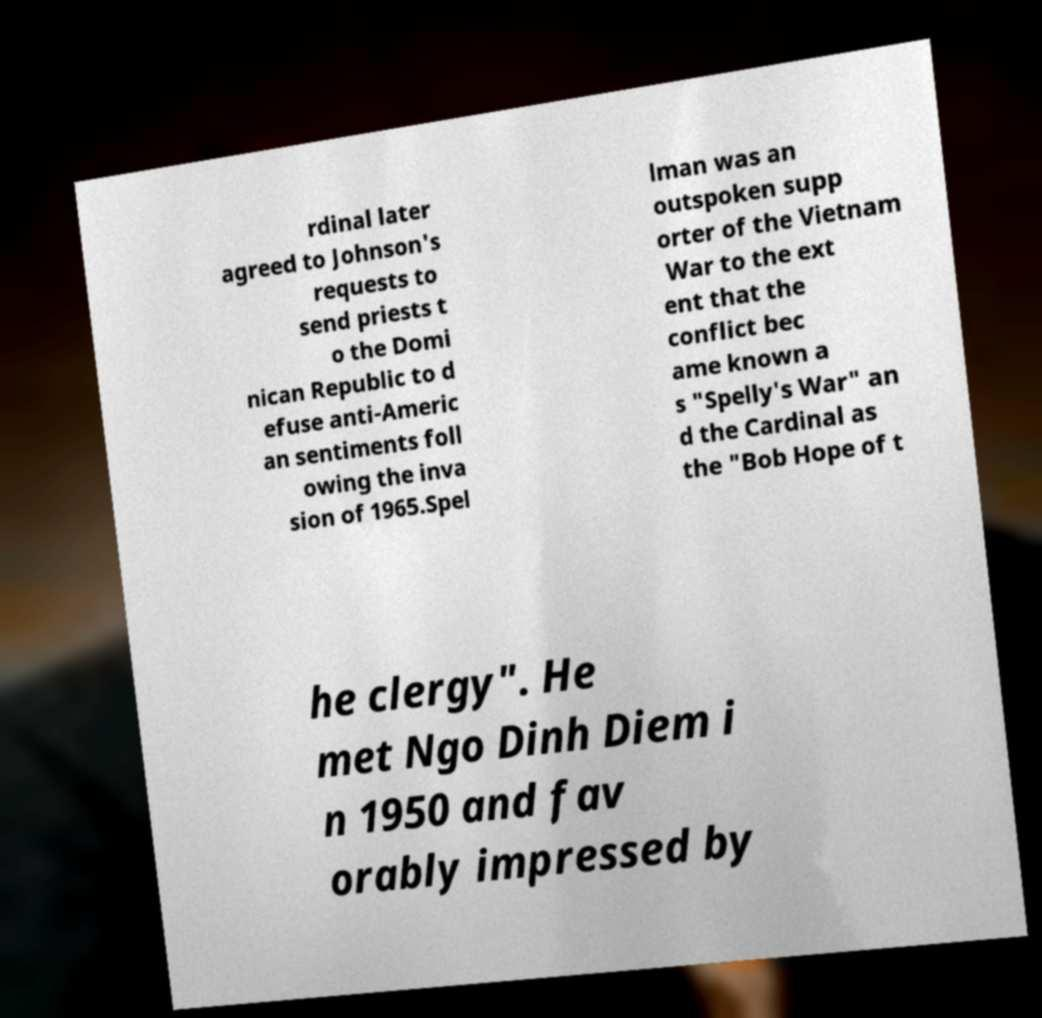Can you read and provide the text displayed in the image?This photo seems to have some interesting text. Can you extract and type it out for me? rdinal later agreed to Johnson's requests to send priests t o the Domi nican Republic to d efuse anti-Americ an sentiments foll owing the inva sion of 1965.Spel lman was an outspoken supp orter of the Vietnam War to the ext ent that the conflict bec ame known a s "Spelly's War" an d the Cardinal as the "Bob Hope of t he clergy". He met Ngo Dinh Diem i n 1950 and fav orably impressed by 